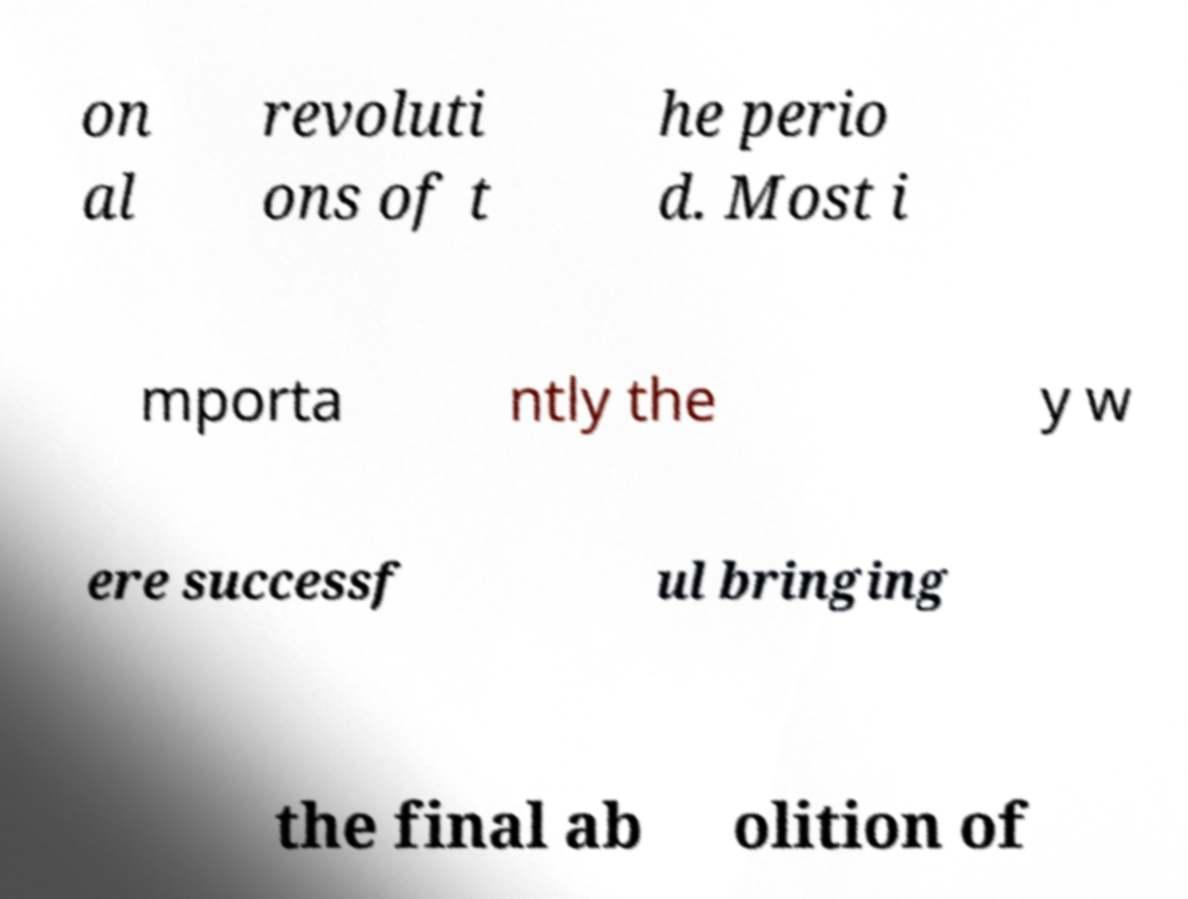Could you extract and type out the text from this image? on al revoluti ons of t he perio d. Most i mporta ntly the y w ere successf ul bringing the final ab olition of 